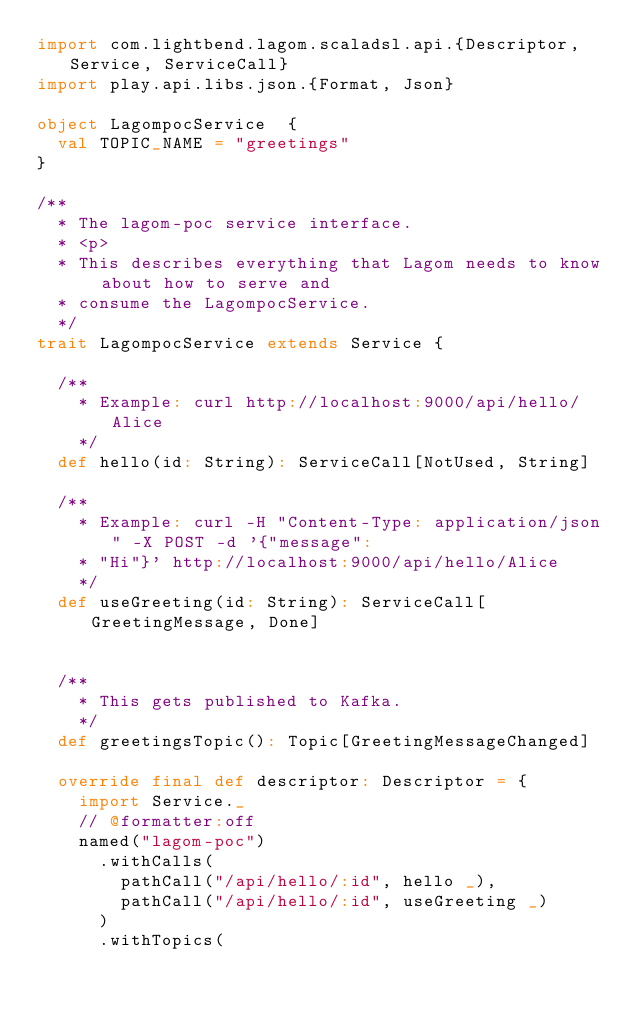Convert code to text. <code><loc_0><loc_0><loc_500><loc_500><_Scala_>import com.lightbend.lagom.scaladsl.api.{Descriptor, Service, ServiceCall}
import play.api.libs.json.{Format, Json}

object LagompocService  {
  val TOPIC_NAME = "greetings"
}

/**
  * The lagom-poc service interface.
  * <p>
  * This describes everything that Lagom needs to know about how to serve and
  * consume the LagompocService.
  */
trait LagompocService extends Service {

  /**
    * Example: curl http://localhost:9000/api/hello/Alice
    */
  def hello(id: String): ServiceCall[NotUsed, String]

  /**
    * Example: curl -H "Content-Type: application/json" -X POST -d '{"message":
    * "Hi"}' http://localhost:9000/api/hello/Alice
    */
  def useGreeting(id: String): ServiceCall[GreetingMessage, Done]


  /**
    * This gets published to Kafka.
    */
  def greetingsTopic(): Topic[GreetingMessageChanged]

  override final def descriptor: Descriptor = {
    import Service._
    // @formatter:off
    named("lagom-poc")
      .withCalls(
        pathCall("/api/hello/:id", hello _),
        pathCall("/api/hello/:id", useGreeting _)
      )
      .withTopics(</code> 